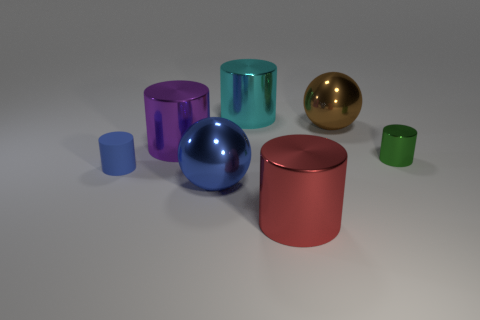There is a metallic cylinder that is both in front of the big purple object and behind the blue cylinder; how big is it? The metallic cylinder in question appears to be of a medium size compared to the other objects in the image. It's tall enough to be seen over the blue cylinder, and its diameter is narrower than the purple object's widest point. Proportionally, it seems to be roughly one-third the height of the purple object and approximately the same height as the blue cylinder. 